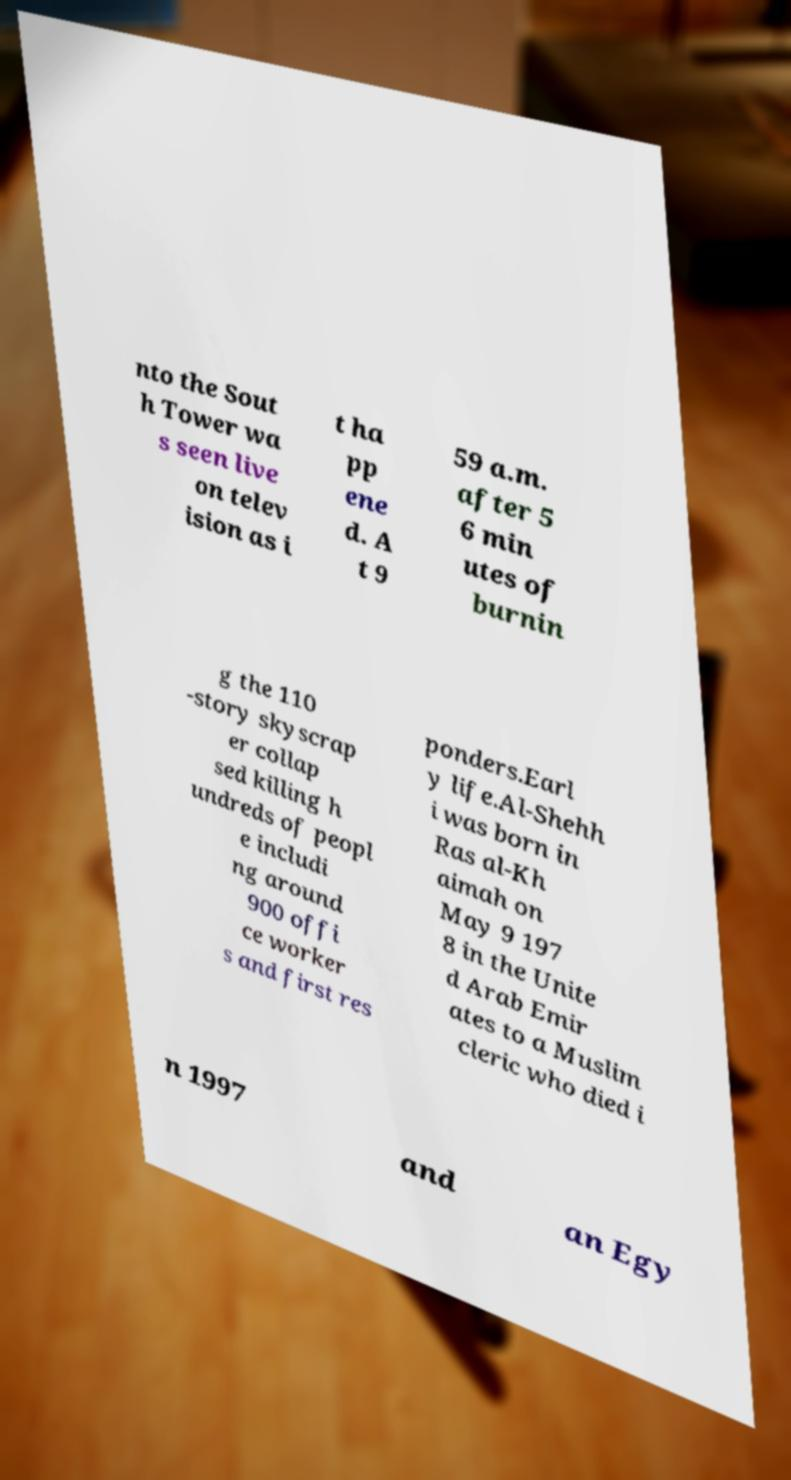Could you assist in decoding the text presented in this image and type it out clearly? nto the Sout h Tower wa s seen live on telev ision as i t ha pp ene d. A t 9 59 a.m. after 5 6 min utes of burnin g the 110 -story skyscrap er collap sed killing h undreds of peopl e includi ng around 900 offi ce worker s and first res ponders.Earl y life.Al-Shehh i was born in Ras al-Kh aimah on May 9 197 8 in the Unite d Arab Emir ates to a Muslim cleric who died i n 1997 and an Egy 